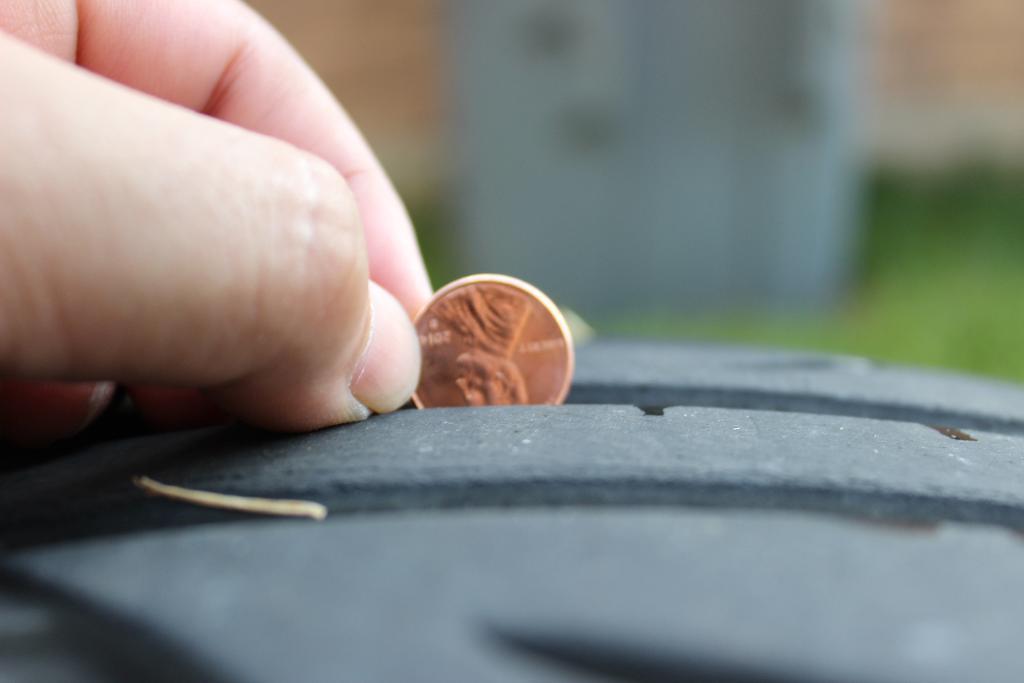Could you give a brief overview of what you see in this image? In this image there is a hand holding a coin, at the bottom there is a box, in the background it is blurred. 